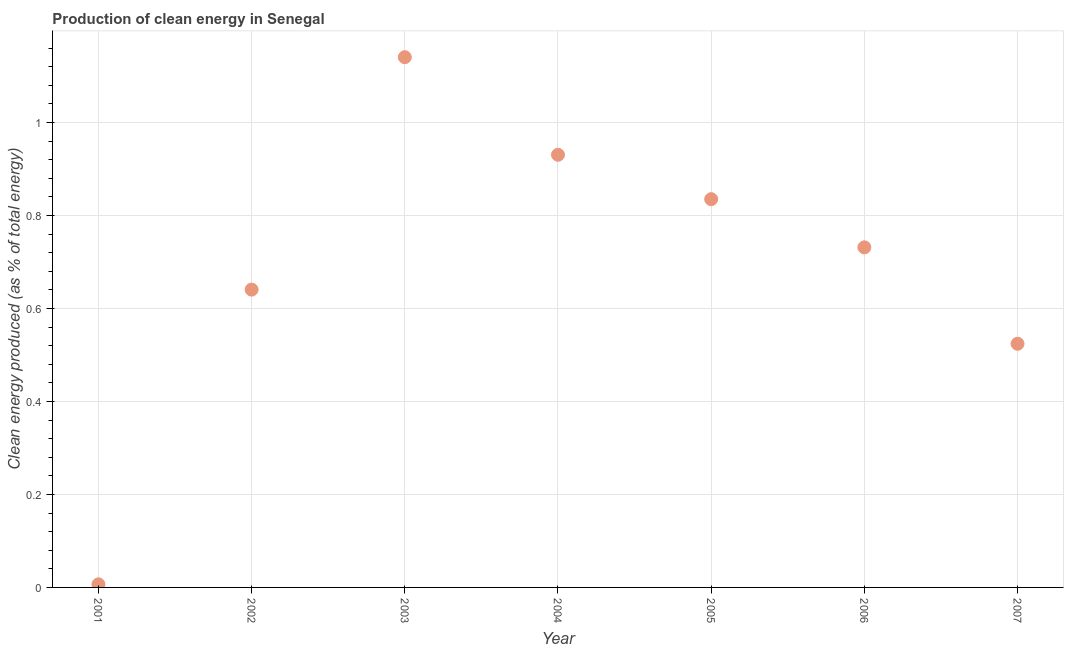What is the production of clean energy in 2001?
Offer a very short reply. 0.01. Across all years, what is the maximum production of clean energy?
Ensure brevity in your answer.  1.14. Across all years, what is the minimum production of clean energy?
Your answer should be compact. 0.01. What is the sum of the production of clean energy?
Ensure brevity in your answer.  4.81. What is the difference between the production of clean energy in 2006 and 2007?
Keep it short and to the point. 0.21. What is the average production of clean energy per year?
Offer a very short reply. 0.69. What is the median production of clean energy?
Your response must be concise. 0.73. In how many years, is the production of clean energy greater than 1 %?
Your answer should be very brief. 1. Do a majority of the years between 2001 and 2006 (inclusive) have production of clean energy greater than 0.44 %?
Provide a short and direct response. Yes. What is the ratio of the production of clean energy in 2001 to that in 2003?
Give a very brief answer. 0.01. Is the production of clean energy in 2005 less than that in 2007?
Provide a succinct answer. No. What is the difference between the highest and the second highest production of clean energy?
Provide a short and direct response. 0.21. What is the difference between the highest and the lowest production of clean energy?
Offer a very short reply. 1.13. In how many years, is the production of clean energy greater than the average production of clean energy taken over all years?
Make the answer very short. 4. Does the graph contain any zero values?
Offer a terse response. No. What is the title of the graph?
Your answer should be compact. Production of clean energy in Senegal. What is the label or title of the X-axis?
Offer a very short reply. Year. What is the label or title of the Y-axis?
Give a very brief answer. Clean energy produced (as % of total energy). What is the Clean energy produced (as % of total energy) in 2001?
Keep it short and to the point. 0.01. What is the Clean energy produced (as % of total energy) in 2002?
Your response must be concise. 0.64. What is the Clean energy produced (as % of total energy) in 2003?
Give a very brief answer. 1.14. What is the Clean energy produced (as % of total energy) in 2004?
Your response must be concise. 0.93. What is the Clean energy produced (as % of total energy) in 2005?
Offer a terse response. 0.84. What is the Clean energy produced (as % of total energy) in 2006?
Provide a short and direct response. 0.73. What is the Clean energy produced (as % of total energy) in 2007?
Give a very brief answer. 0.52. What is the difference between the Clean energy produced (as % of total energy) in 2001 and 2002?
Your response must be concise. -0.63. What is the difference between the Clean energy produced (as % of total energy) in 2001 and 2003?
Offer a very short reply. -1.13. What is the difference between the Clean energy produced (as % of total energy) in 2001 and 2004?
Your response must be concise. -0.92. What is the difference between the Clean energy produced (as % of total energy) in 2001 and 2005?
Keep it short and to the point. -0.83. What is the difference between the Clean energy produced (as % of total energy) in 2001 and 2006?
Make the answer very short. -0.72. What is the difference between the Clean energy produced (as % of total energy) in 2001 and 2007?
Your answer should be compact. -0.52. What is the difference between the Clean energy produced (as % of total energy) in 2002 and 2003?
Offer a terse response. -0.5. What is the difference between the Clean energy produced (as % of total energy) in 2002 and 2004?
Your answer should be very brief. -0.29. What is the difference between the Clean energy produced (as % of total energy) in 2002 and 2005?
Your response must be concise. -0.19. What is the difference between the Clean energy produced (as % of total energy) in 2002 and 2006?
Offer a terse response. -0.09. What is the difference between the Clean energy produced (as % of total energy) in 2002 and 2007?
Ensure brevity in your answer.  0.12. What is the difference between the Clean energy produced (as % of total energy) in 2003 and 2004?
Keep it short and to the point. 0.21. What is the difference between the Clean energy produced (as % of total energy) in 2003 and 2005?
Your answer should be compact. 0.31. What is the difference between the Clean energy produced (as % of total energy) in 2003 and 2006?
Your answer should be very brief. 0.41. What is the difference between the Clean energy produced (as % of total energy) in 2003 and 2007?
Provide a short and direct response. 0.62. What is the difference between the Clean energy produced (as % of total energy) in 2004 and 2005?
Your answer should be very brief. 0.1. What is the difference between the Clean energy produced (as % of total energy) in 2004 and 2006?
Give a very brief answer. 0.2. What is the difference between the Clean energy produced (as % of total energy) in 2004 and 2007?
Offer a very short reply. 0.41. What is the difference between the Clean energy produced (as % of total energy) in 2005 and 2006?
Keep it short and to the point. 0.1. What is the difference between the Clean energy produced (as % of total energy) in 2005 and 2007?
Offer a terse response. 0.31. What is the difference between the Clean energy produced (as % of total energy) in 2006 and 2007?
Your response must be concise. 0.21. What is the ratio of the Clean energy produced (as % of total energy) in 2001 to that in 2002?
Provide a short and direct response. 0.01. What is the ratio of the Clean energy produced (as % of total energy) in 2001 to that in 2003?
Your answer should be compact. 0.01. What is the ratio of the Clean energy produced (as % of total energy) in 2001 to that in 2004?
Make the answer very short. 0.01. What is the ratio of the Clean energy produced (as % of total energy) in 2001 to that in 2005?
Your answer should be compact. 0.01. What is the ratio of the Clean energy produced (as % of total energy) in 2001 to that in 2006?
Give a very brief answer. 0.01. What is the ratio of the Clean energy produced (as % of total energy) in 2001 to that in 2007?
Ensure brevity in your answer.  0.01. What is the ratio of the Clean energy produced (as % of total energy) in 2002 to that in 2003?
Your answer should be very brief. 0.56. What is the ratio of the Clean energy produced (as % of total energy) in 2002 to that in 2004?
Your answer should be compact. 0.69. What is the ratio of the Clean energy produced (as % of total energy) in 2002 to that in 2005?
Make the answer very short. 0.77. What is the ratio of the Clean energy produced (as % of total energy) in 2002 to that in 2006?
Your response must be concise. 0.88. What is the ratio of the Clean energy produced (as % of total energy) in 2002 to that in 2007?
Offer a terse response. 1.22. What is the ratio of the Clean energy produced (as % of total energy) in 2003 to that in 2004?
Your answer should be very brief. 1.23. What is the ratio of the Clean energy produced (as % of total energy) in 2003 to that in 2005?
Make the answer very short. 1.37. What is the ratio of the Clean energy produced (as % of total energy) in 2003 to that in 2006?
Make the answer very short. 1.56. What is the ratio of the Clean energy produced (as % of total energy) in 2003 to that in 2007?
Make the answer very short. 2.18. What is the ratio of the Clean energy produced (as % of total energy) in 2004 to that in 2005?
Provide a short and direct response. 1.11. What is the ratio of the Clean energy produced (as % of total energy) in 2004 to that in 2006?
Make the answer very short. 1.27. What is the ratio of the Clean energy produced (as % of total energy) in 2004 to that in 2007?
Your answer should be compact. 1.78. What is the ratio of the Clean energy produced (as % of total energy) in 2005 to that in 2006?
Ensure brevity in your answer.  1.14. What is the ratio of the Clean energy produced (as % of total energy) in 2005 to that in 2007?
Offer a terse response. 1.59. What is the ratio of the Clean energy produced (as % of total energy) in 2006 to that in 2007?
Make the answer very short. 1.4. 